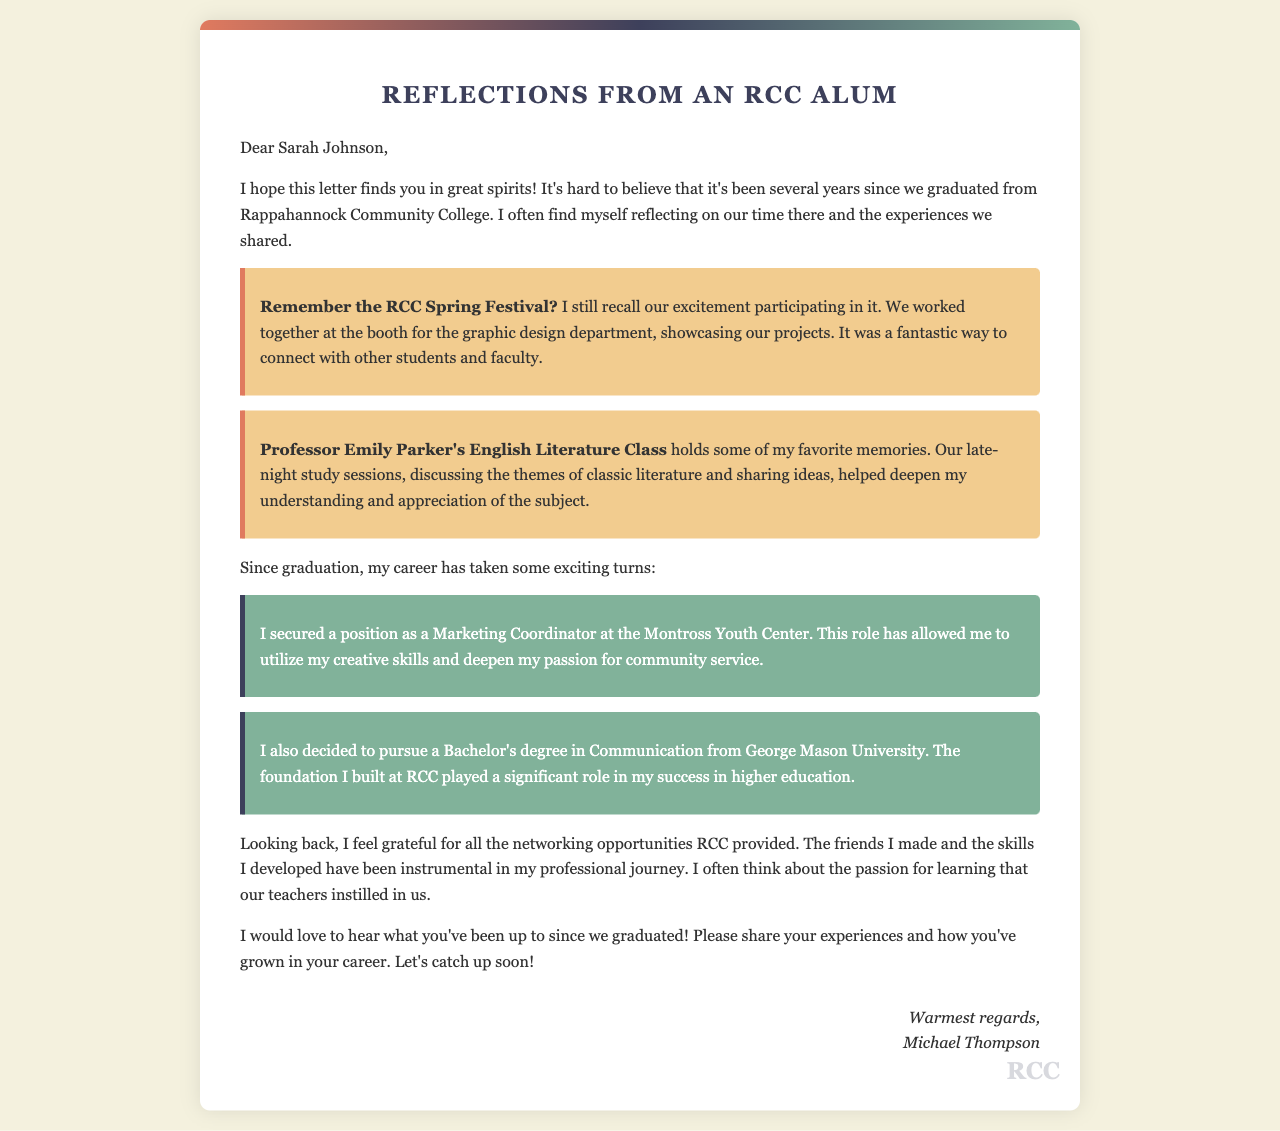what is the name of the recipient? The recipient of the letter is mentioned at the beginning and is named Sarah Johnson.
Answer: Sarah Johnson what is the main subject of the letter? The letter reflects on shared experiences and career growth since graduation from Rappahannock Community College.
Answer: Reflections from an RCC Alum who is the sender of the letter? The sender is identified at the end of the letter as Michael Thompson.
Answer: Michael Thompson what position did the sender secure after graduation? The document states that the sender secured a position as a Marketing Coordinator at the Montross Youth Center.
Answer: Marketing Coordinator what degree is the sender pursuing? The sender mentions that they decided to pursue a Bachelor's degree in Communication.
Answer: Bachelor's degree in Communication which professor's class is mentioned in the letter? The letter specifically refers to Professor Emily Parker's English Literature Class.
Answer: Professor Emily Parker which event is remembered fondly by the sender? The sender recalls the RCC Spring Festival as a memorable event.
Answer: RCC Spring Festival what type of opportunities does the sender express gratitude for? The sender expresses gratitude for the networking opportunities provided by RCC.
Answer: Networking opportunities when was the letter written? The letter does not specify an exact date, but it mentions "several years since we graduated."
Answer: Several years since graduation 